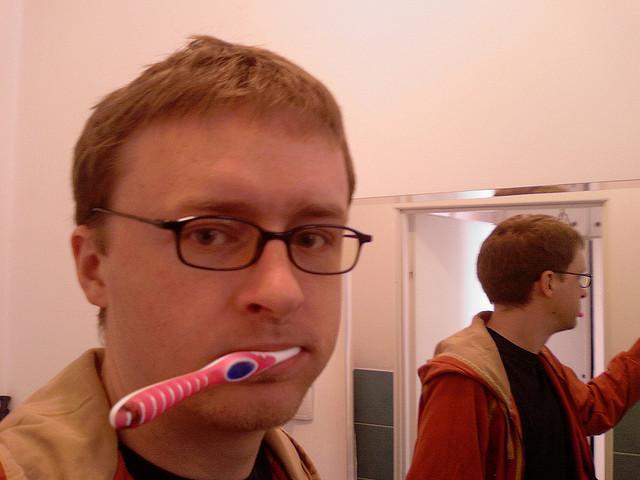How many people are in the photo?
Give a very brief answer. 2. 